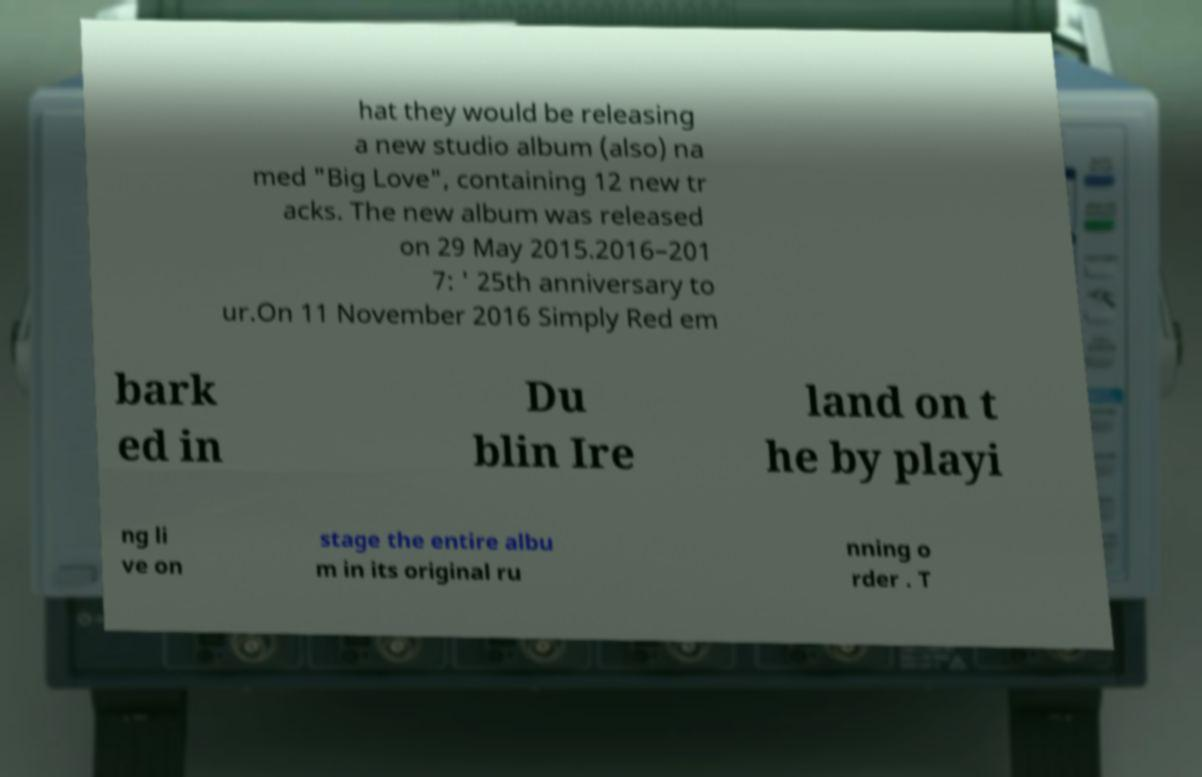Could you assist in decoding the text presented in this image and type it out clearly? hat they would be releasing a new studio album (also) na med "Big Love", containing 12 new tr acks. The new album was released on 29 May 2015.2016–201 7: ' 25th anniversary to ur.On 11 November 2016 Simply Red em bark ed in Du blin Ire land on t he by playi ng li ve on stage the entire albu m in its original ru nning o rder . T 